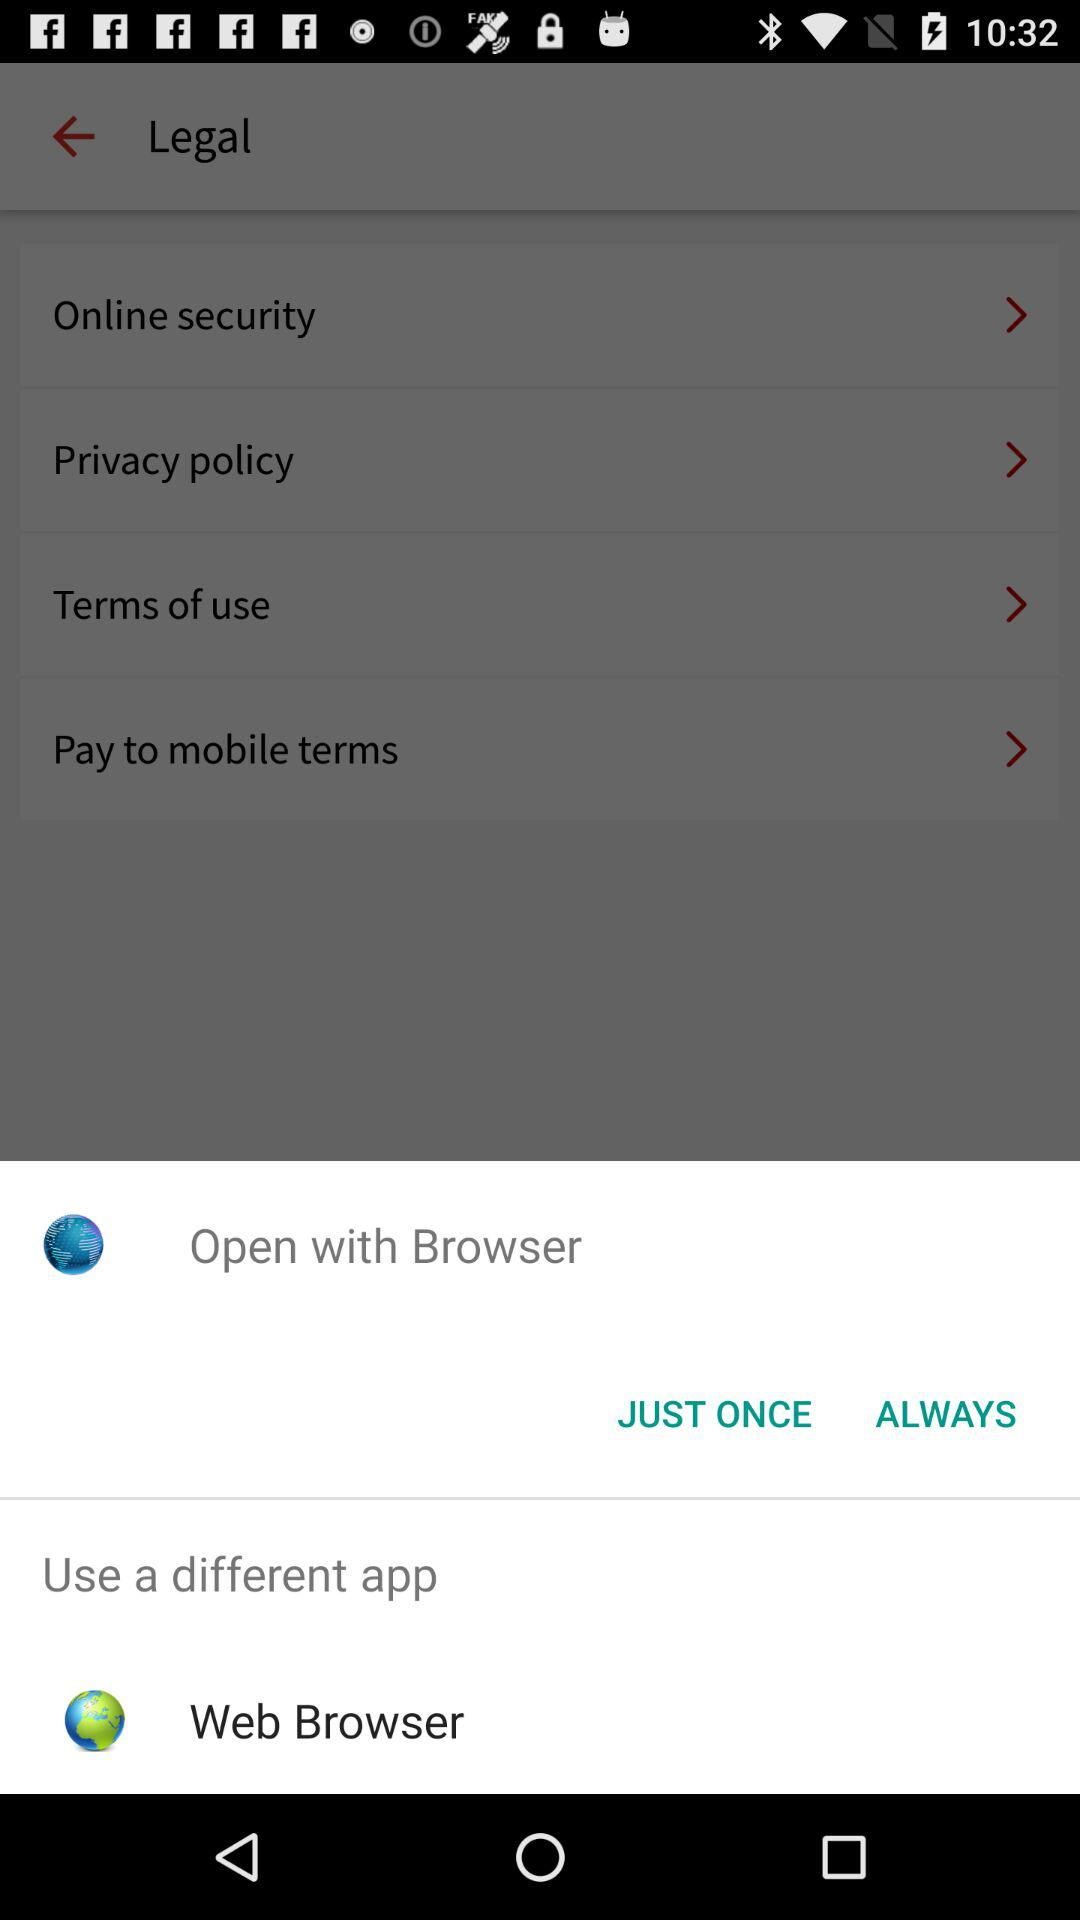How many terms are there in total?
Answer the question using a single word or phrase. 4 